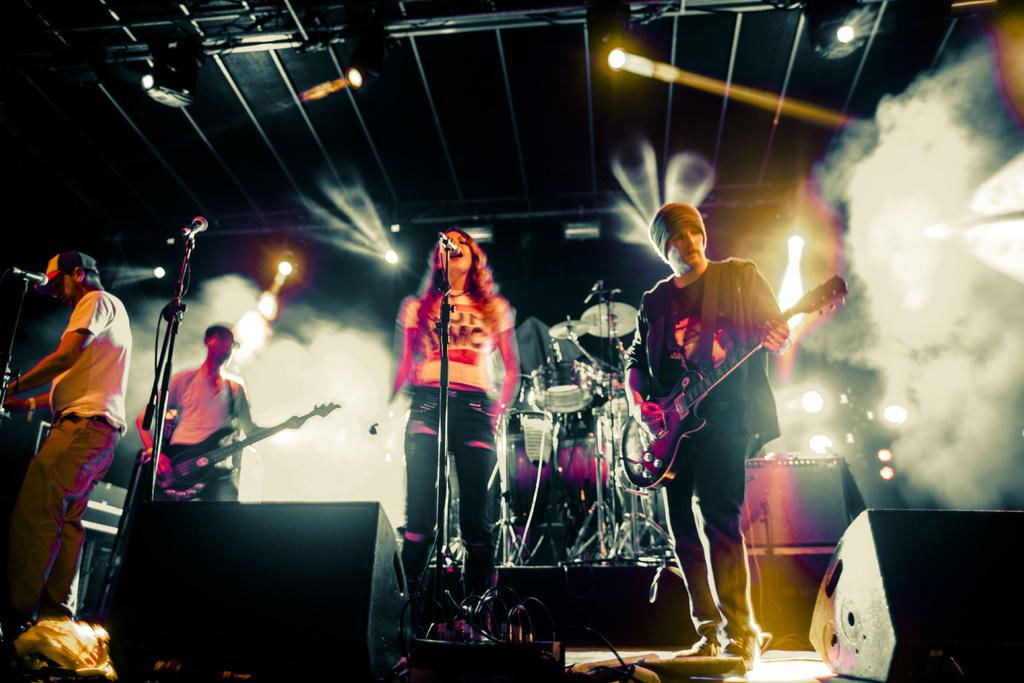What can be seen in the image? There are people standing in the image. What objects are present in the image? There are microphones in the image. Can you describe the woman in the image? A woman is standing next to the microphones. What type of tooth is the woman using to adjust the microphone in the image? There is no tooth present in the image, and the woman is not using any tooth to adjust the microphone. 